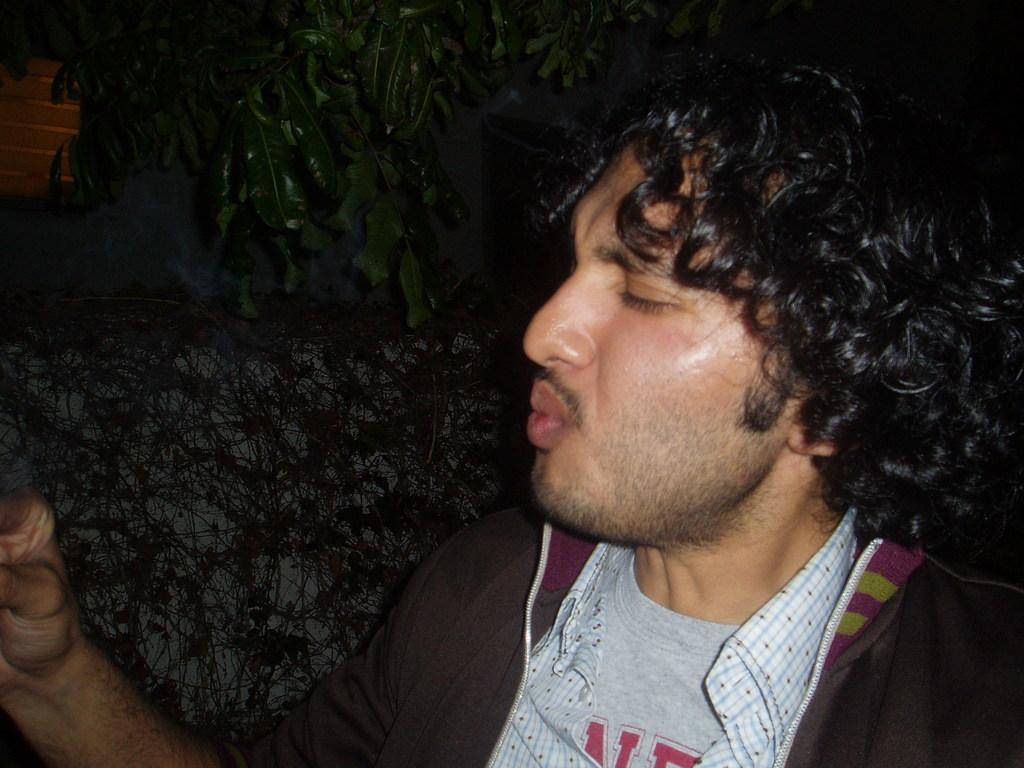Could you give a brief overview of what you see in this image? In this there is a person standing, in the background there are trees. 